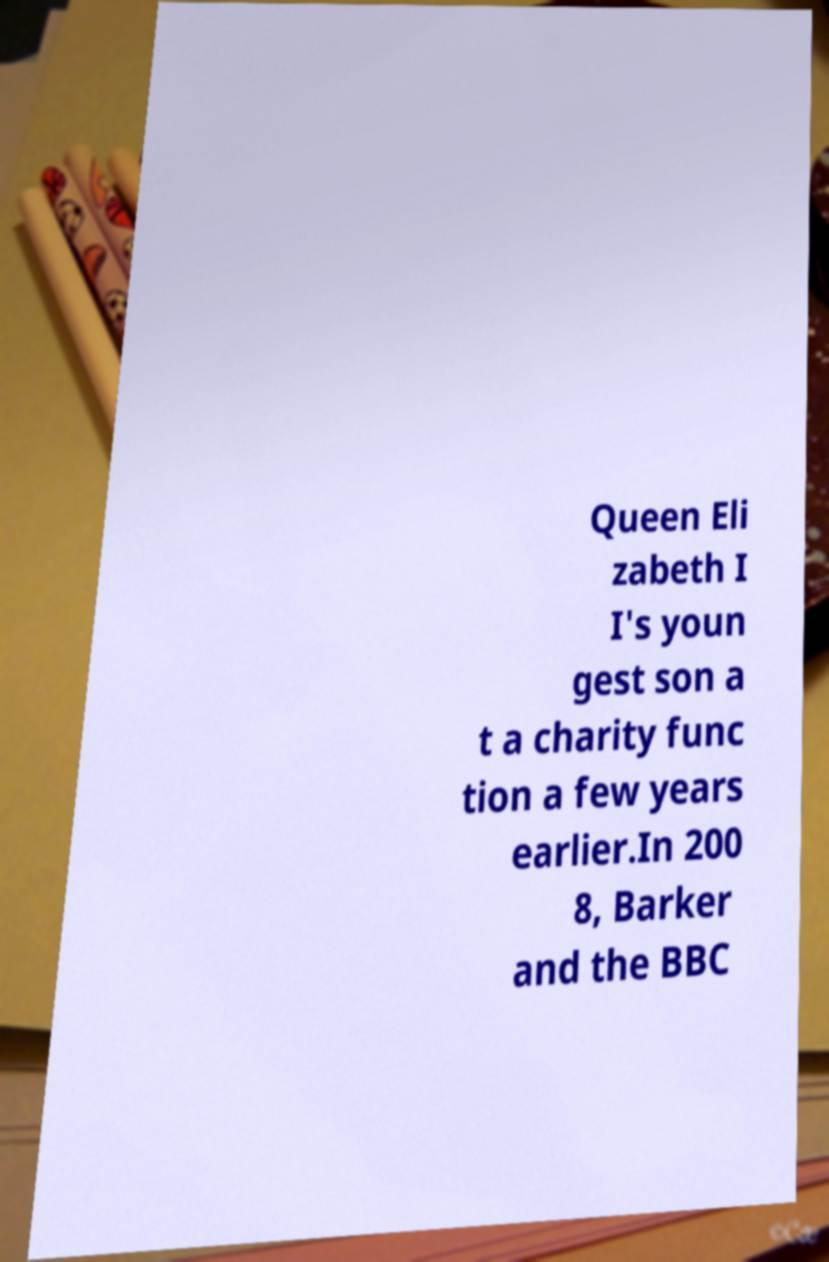What messages or text are displayed in this image? I need them in a readable, typed format. Queen Eli zabeth I I's youn gest son a t a charity func tion a few years earlier.In 200 8, Barker and the BBC 